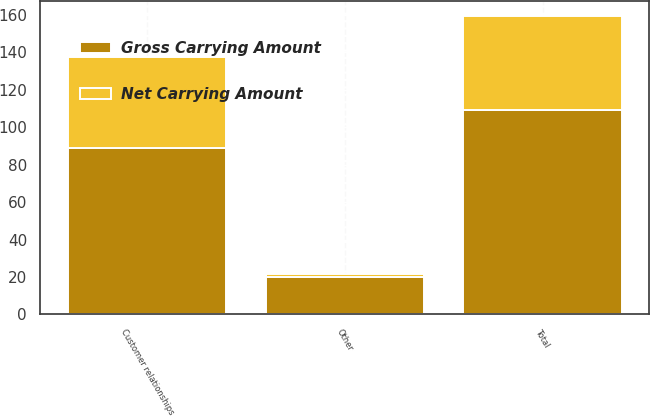<chart> <loc_0><loc_0><loc_500><loc_500><stacked_bar_chart><ecel><fcel>Customer relationships<fcel>Other<fcel>Total<nl><fcel>Gross Carrying Amount<fcel>89.1<fcel>19.9<fcel>109<nl><fcel>Net Carrying Amount<fcel>48.6<fcel>1.7<fcel>50.3<nl></chart> 